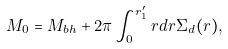Convert formula to latex. <formula><loc_0><loc_0><loc_500><loc_500>M _ { 0 } = M _ { b h } + 2 \pi \int _ { 0 } ^ { r _ { 1 } ^ { \prime } } r d r \Sigma _ { d } ( r ) ,</formula> 